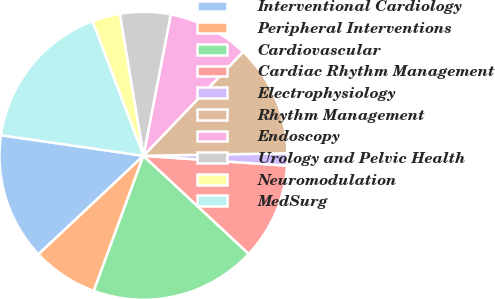<chart> <loc_0><loc_0><loc_500><loc_500><pie_chart><fcel>Interventional Cardiology<fcel>Peripheral Interventions<fcel>Cardiovascular<fcel>Cardiac Rhythm Management<fcel>Electrophysiology<fcel>Rhythm Management<fcel>Endoscopy<fcel>Urology and Pelvic Health<fcel>Neuromodulation<fcel>MedSurg<nl><fcel>14.28%<fcel>7.4%<fcel>18.67%<fcel>10.84%<fcel>1.37%<fcel>12.56%<fcel>9.12%<fcel>5.67%<fcel>3.14%<fcel>16.95%<nl></chart> 